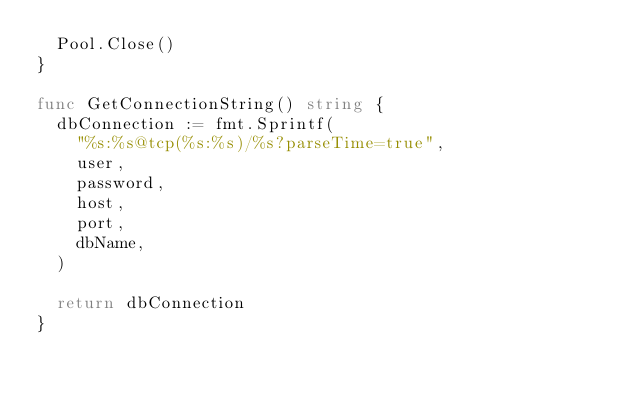<code> <loc_0><loc_0><loc_500><loc_500><_Go_>	Pool.Close()
}

func GetConnectionString() string {
	dbConnection := fmt.Sprintf(
		"%s:%s@tcp(%s:%s)/%s?parseTime=true",
		user,
		password,
		host,
		port,
		dbName,
	)

	return dbConnection
}
</code> 